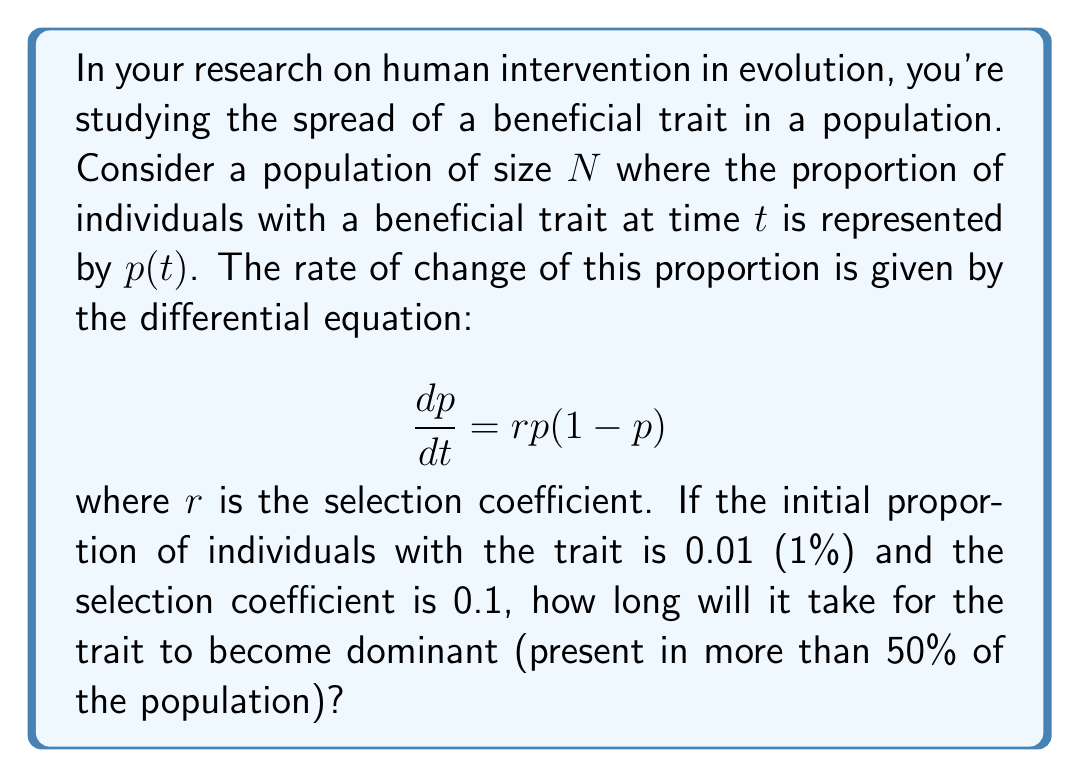Can you solve this math problem? To solve this problem, we need to integrate the differential equation and solve for t when p = 0.5. Let's break it down step-by-step:

1) First, we separate the variables:

   $$\frac{dp}{p(1-p)} = rdt$$

2) Integrate both sides:

   $$\int \frac{dp}{p(1-p)} = \int rdt$$

3) The left side can be integrated using partial fractions:

   $$\ln|\frac{p}{1-p}| = rt + C$$

4) Solve for p:

   $$\frac{p}{1-p} = e^{rt + C} = Ke^{rt}$$

   where $K = e^C$

5) Rearrange to get p in terms of t:

   $$p = \frac{Ke^{rt}}{1 + Ke^{rt}}$$

6) Use the initial condition p(0) = 0.01 to find K:

   $$0.01 = \frac{K}{1 + K}$$
   $$K = \frac{0.01}{0.99} \approx 0.0101$$

7) Now we have the solution:

   $$p(t) = \frac{0.0101e^{0.1t}}{1 + 0.0101e^{0.1t}}$$

8) To find when p = 0.5, we solve:

   $$0.5 = \frac{0.0101e^{0.1t}}{1 + 0.0101e^{0.1t}}$$

9) Simplify and solve for t:

   $$e^{0.1t} = \frac{0.5}{0.0101(1-0.5)} \approx 99$$
   $$0.1t = \ln(99)$$
   $$t = \frac{\ln(99)}{0.1} \approx 45.96$$

Therefore, it will take approximately 45.96 time units for the trait to become dominant in the population.
Answer: Approximately 45.96 time units 